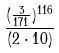<formula> <loc_0><loc_0><loc_500><loc_500>\frac { ( \frac { 3 } { 1 7 1 } ) ^ { 1 1 6 } } { ( 2 \cdot 1 0 ) }</formula> 